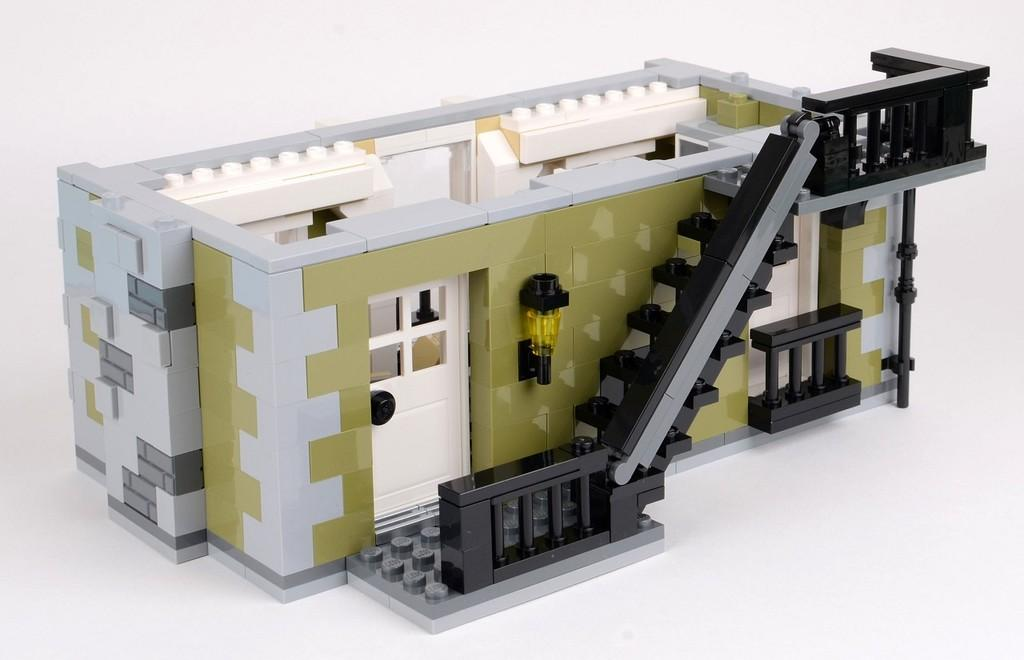What is present on the table in the image? There is a toy building on the table. What is the toy building made of? The toy building is made of building blocks. What type of powder can be seen covering the playground in the image? There is no playground or powder present in the image; it features a table with a toy building made of building blocks. 